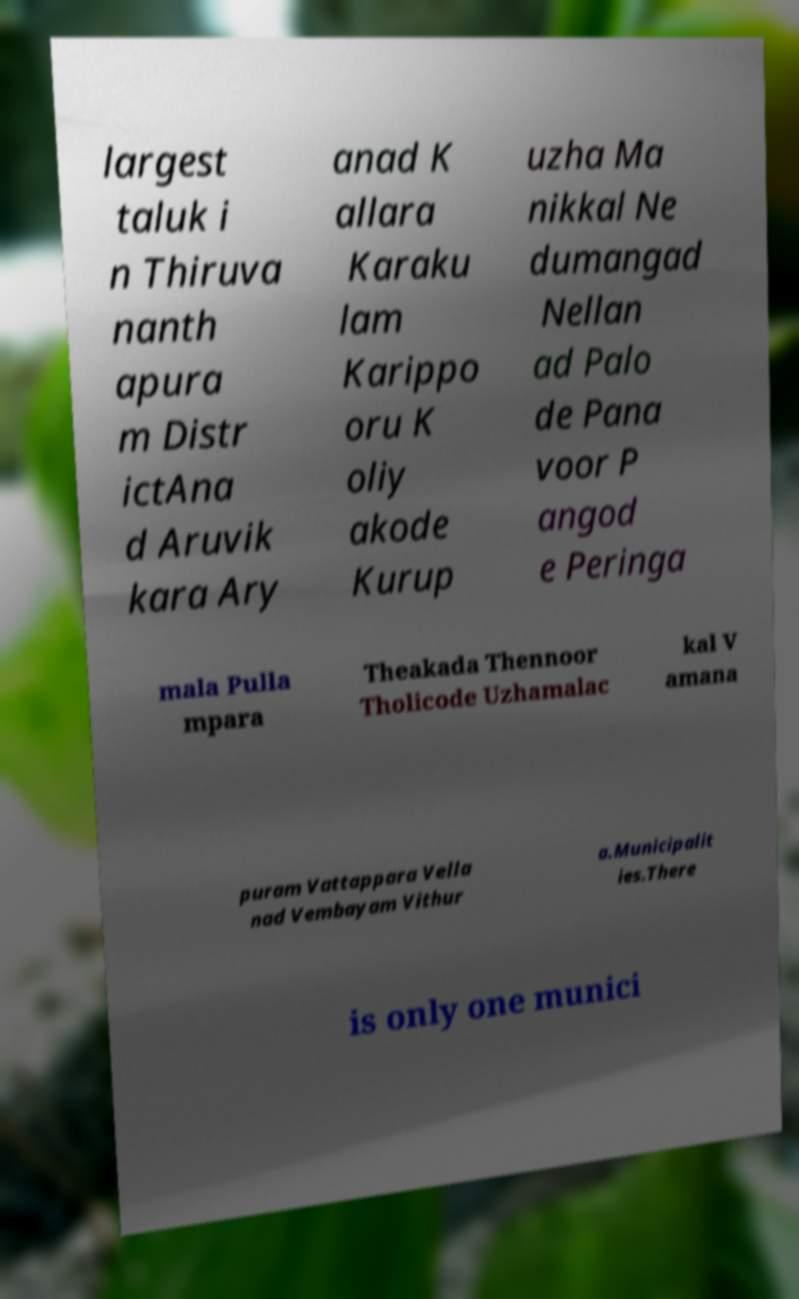There's text embedded in this image that I need extracted. Can you transcribe it verbatim? largest taluk i n Thiruva nanth apura m Distr ictAna d Aruvik kara Ary anad K allara Karaku lam Karippo oru K oliy akode Kurup uzha Ma nikkal Ne dumangad Nellan ad Palo de Pana voor P angod e Peringa mala Pulla mpara Theakada Thennoor Tholicode Uzhamalac kal V amana puram Vattappara Vella nad Vembayam Vithur a.Municipalit ies.There is only one munici 